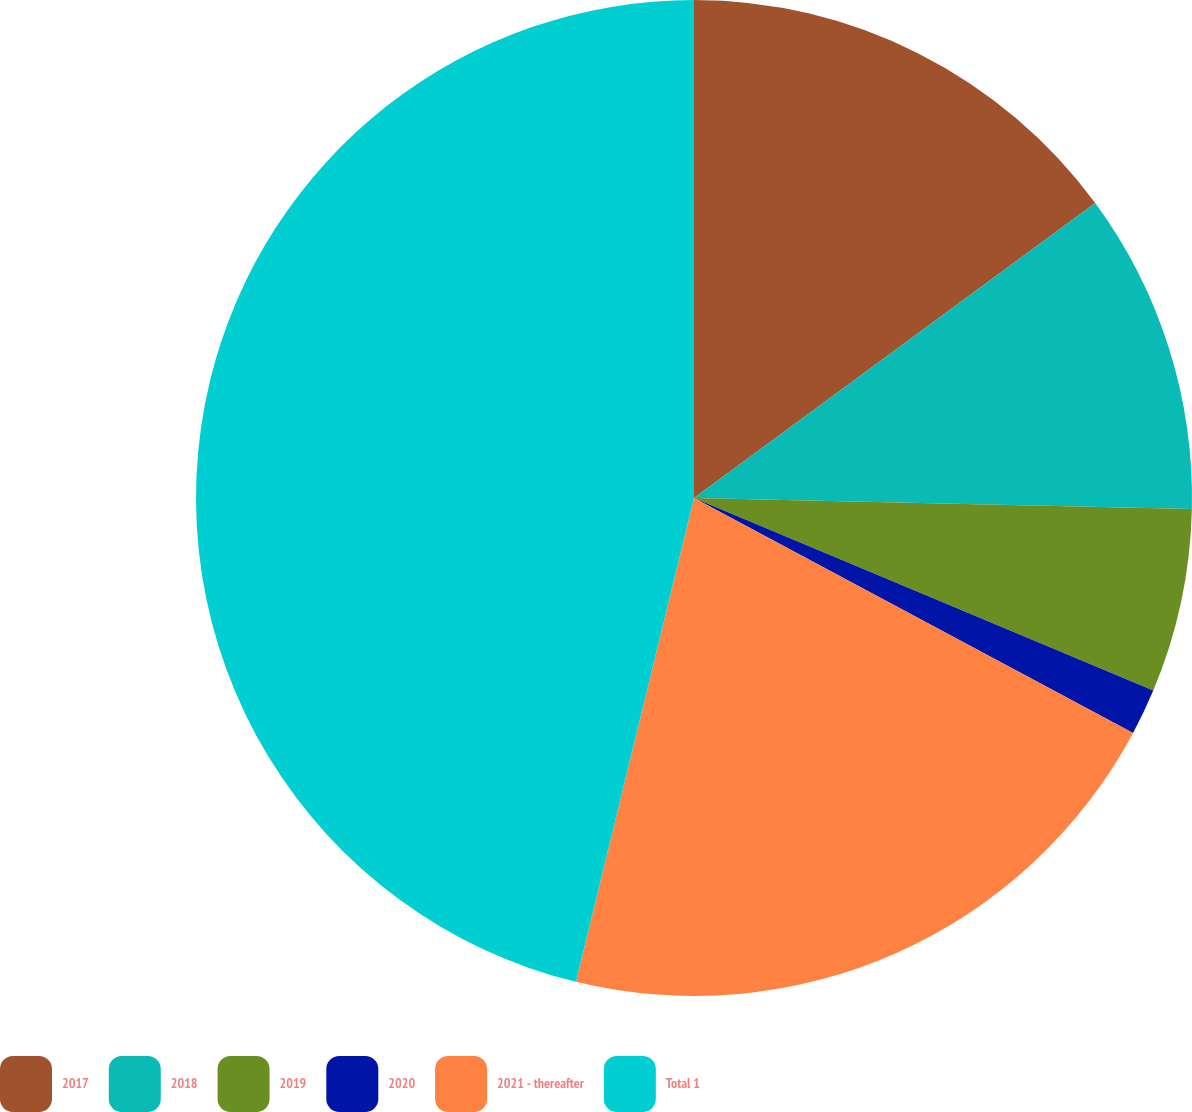Convert chart. <chart><loc_0><loc_0><loc_500><loc_500><pie_chart><fcel>2017<fcel>2018<fcel>2019<fcel>2020<fcel>2021 - thereafter<fcel>Total 1<nl><fcel>14.91%<fcel>10.44%<fcel>5.97%<fcel>1.5%<fcel>20.99%<fcel>46.19%<nl></chart> 